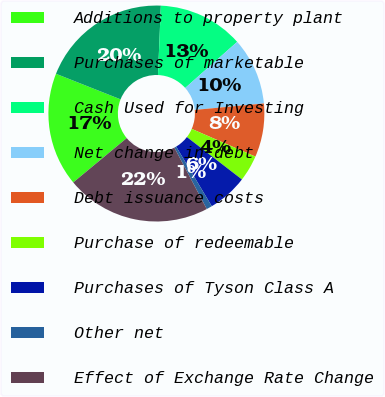<chart> <loc_0><loc_0><loc_500><loc_500><pie_chart><fcel>Additions to property plant<fcel>Purchases of marketable<fcel>Cash Used for Investing<fcel>Net change in debt<fcel>Debt issuance costs<fcel>Purchase of redeemable<fcel>Purchases of Tyson Class A<fcel>Other net<fcel>Effect of Exchange Rate Change<nl><fcel>17.01%<fcel>19.66%<fcel>12.79%<fcel>10.06%<fcel>8.02%<fcel>3.92%<fcel>5.97%<fcel>0.85%<fcel>21.71%<nl></chart> 